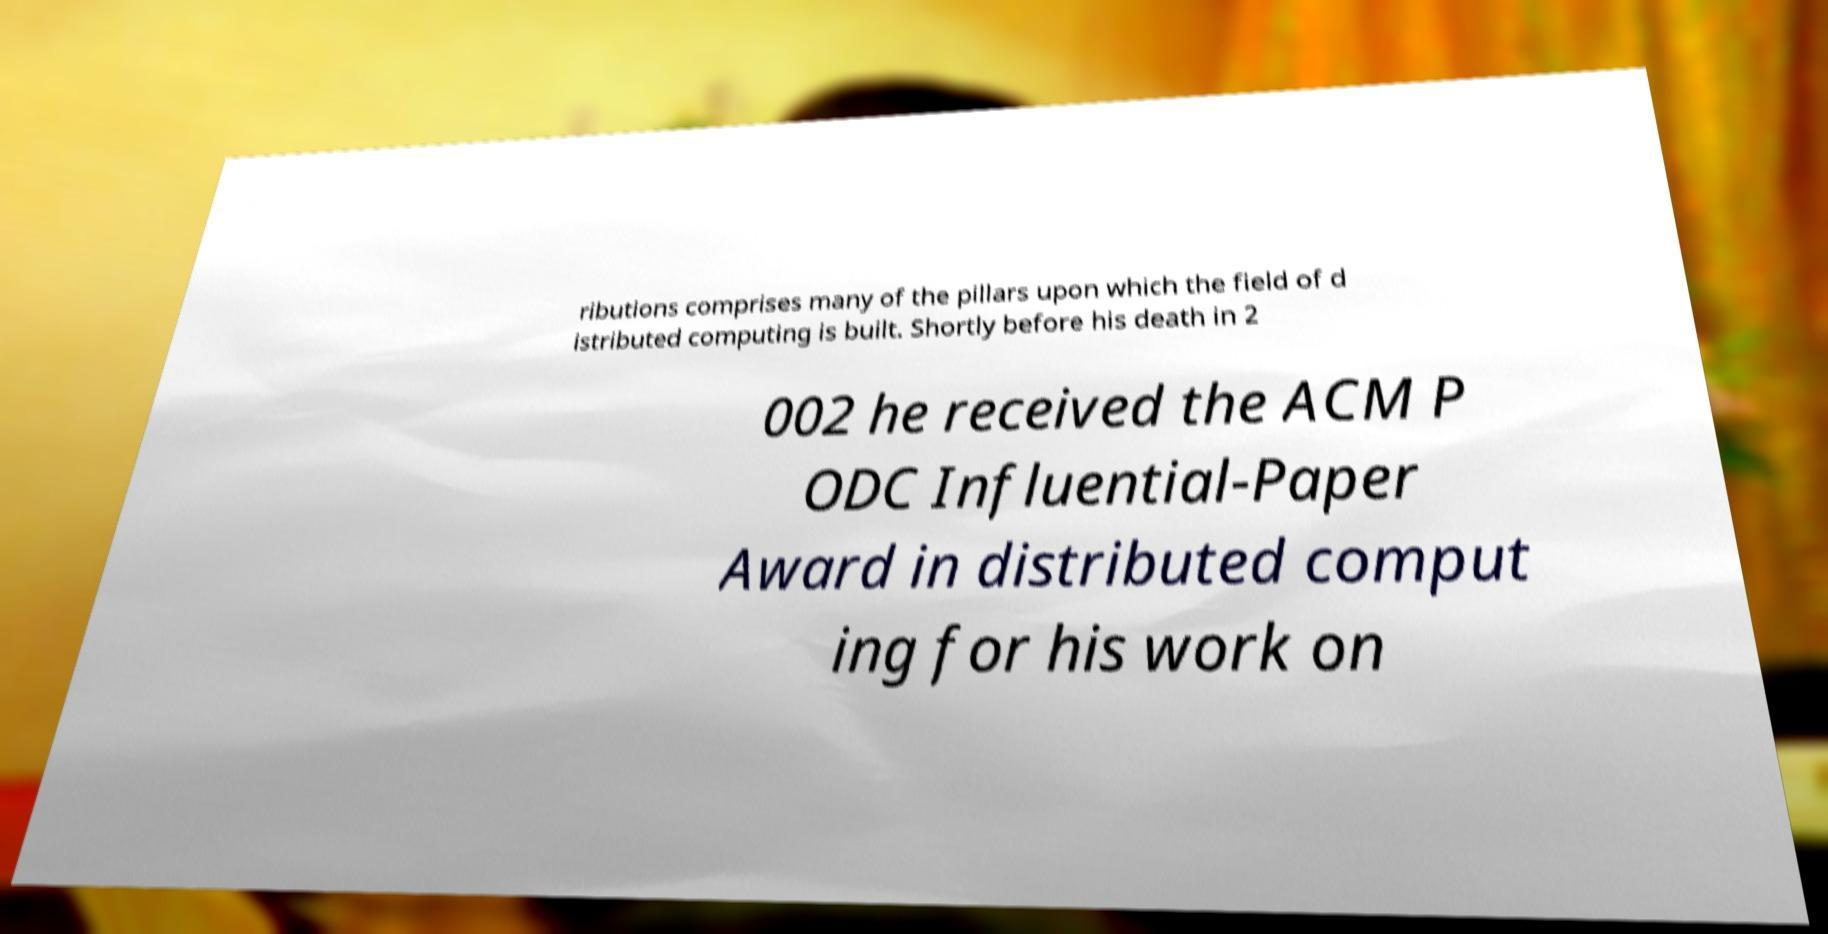Could you extract and type out the text from this image? ributions comprises many of the pillars upon which the field of d istributed computing is built. Shortly before his death in 2 002 he received the ACM P ODC Influential-Paper Award in distributed comput ing for his work on 